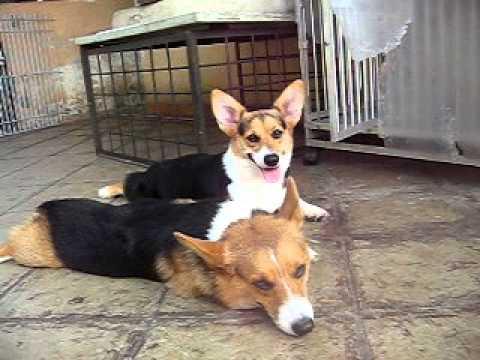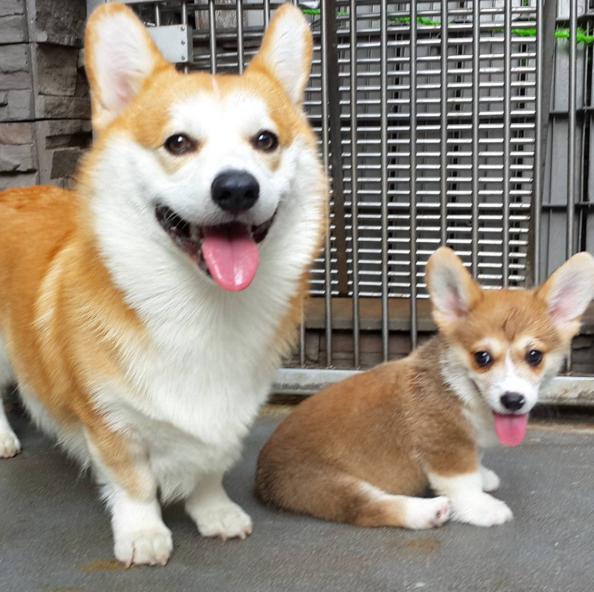The first image is the image on the left, the second image is the image on the right. For the images displayed, is the sentence "One image shows dogs asleep and the other image shows dogs awake." factually correct? Answer yes or no. No. The first image is the image on the left, the second image is the image on the right. For the images displayed, is the sentence "There are exactly two dogs." factually correct? Answer yes or no. No. 